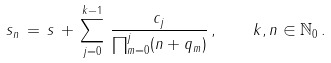<formula> <loc_0><loc_0><loc_500><loc_500>s _ { n } \, = \, s \, + \, \sum _ { j = 0 } ^ { k - 1 } \, \frac { c _ { j } } { \prod _ { m = 0 } ^ { j } ( n + q _ { m } ) } \, , \quad k , n \in \mathbb { N } _ { 0 } \, .</formula> 